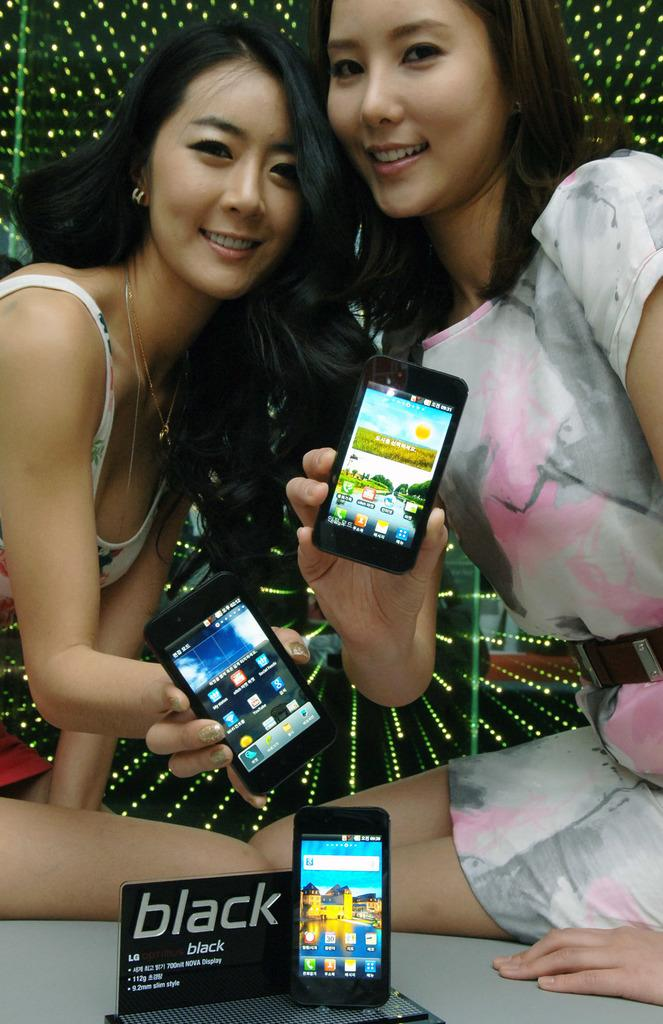How many people are in the image? There are two women in the image. What are the women doing in the image? The women are sitting. What objects are the women holding in their hands? The women are holding mobile phones in their hands. Is there anything else related to communication devices on the table? Yes, there is a mobile phone on the table. What type of cabbage is being used as a table decoration in the image? There is no cabbage present in the image. Can you see a goat in the image? No, there is no goat in the image. 